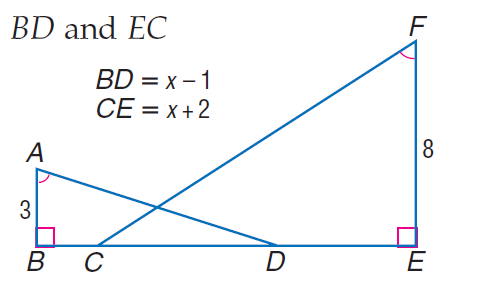Answer the mathemtical geometry problem and directly provide the correct option letter.
Question: Find E C.
Choices: A: 4.8 B: 5.2 C: 11 D: 12 A 